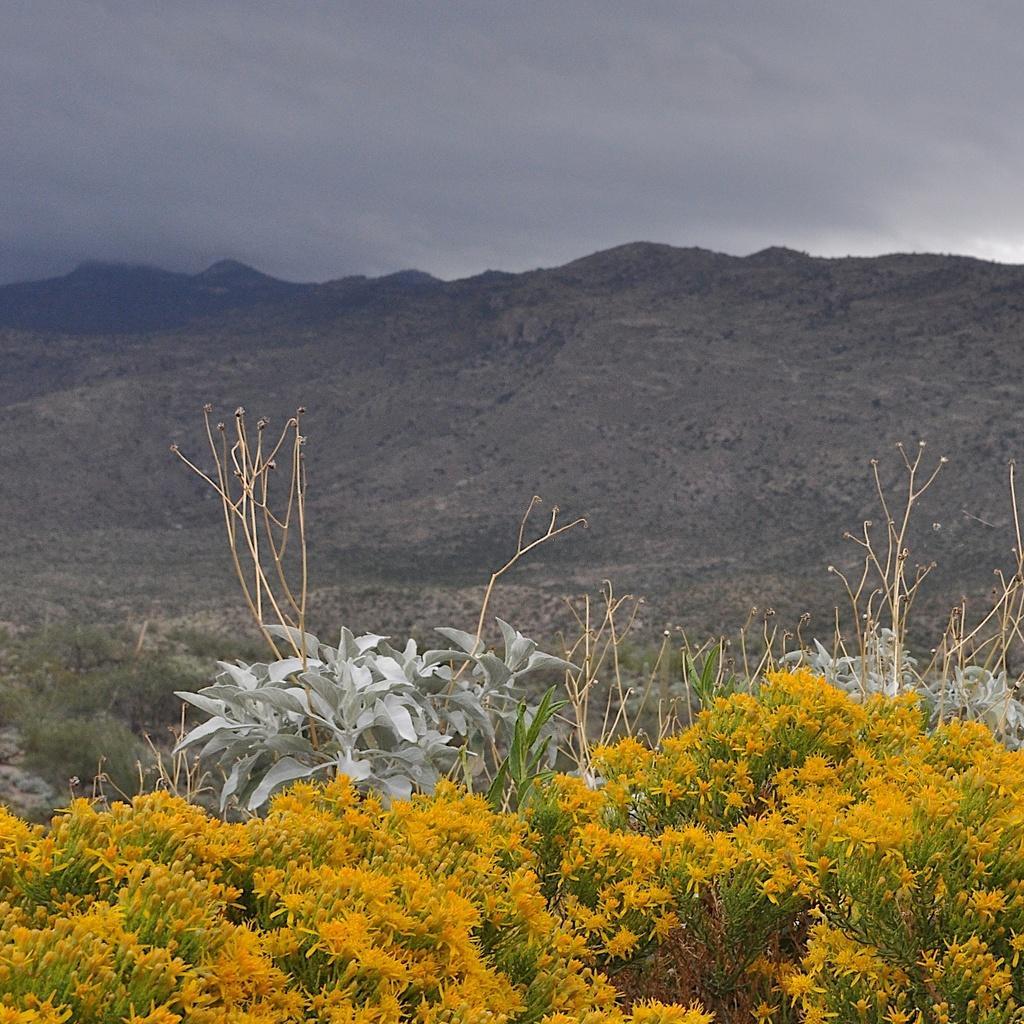Please provide a concise description of this image. At the bottom there are yellow color flowers. In the back there are plants. Also there are hills and sky with clouds. 